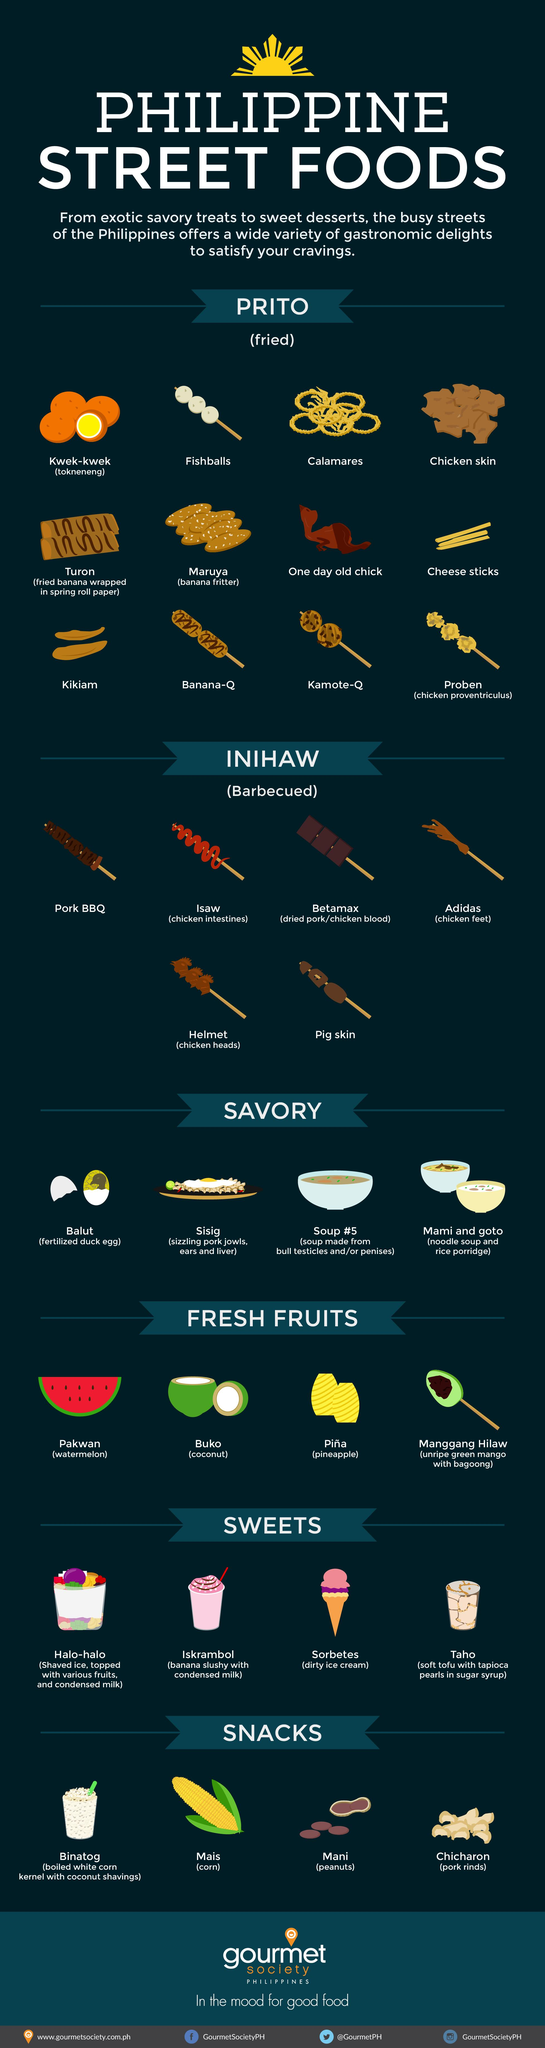Identify some key points in this picture. Coconut is known as Buko in the Filipino language. Binatog, Mani, and Chicharon are all non-veg snacks, but Chicharon is the only one in the list. What is the Filipino name for rice porridge? It is known as Goto. The two fried dishes that contain banana as the primary ingredient are Turon and Maruya. In the Philippines, desserts such as halo-halo and iskrambol are commonly served with condensed milk. 